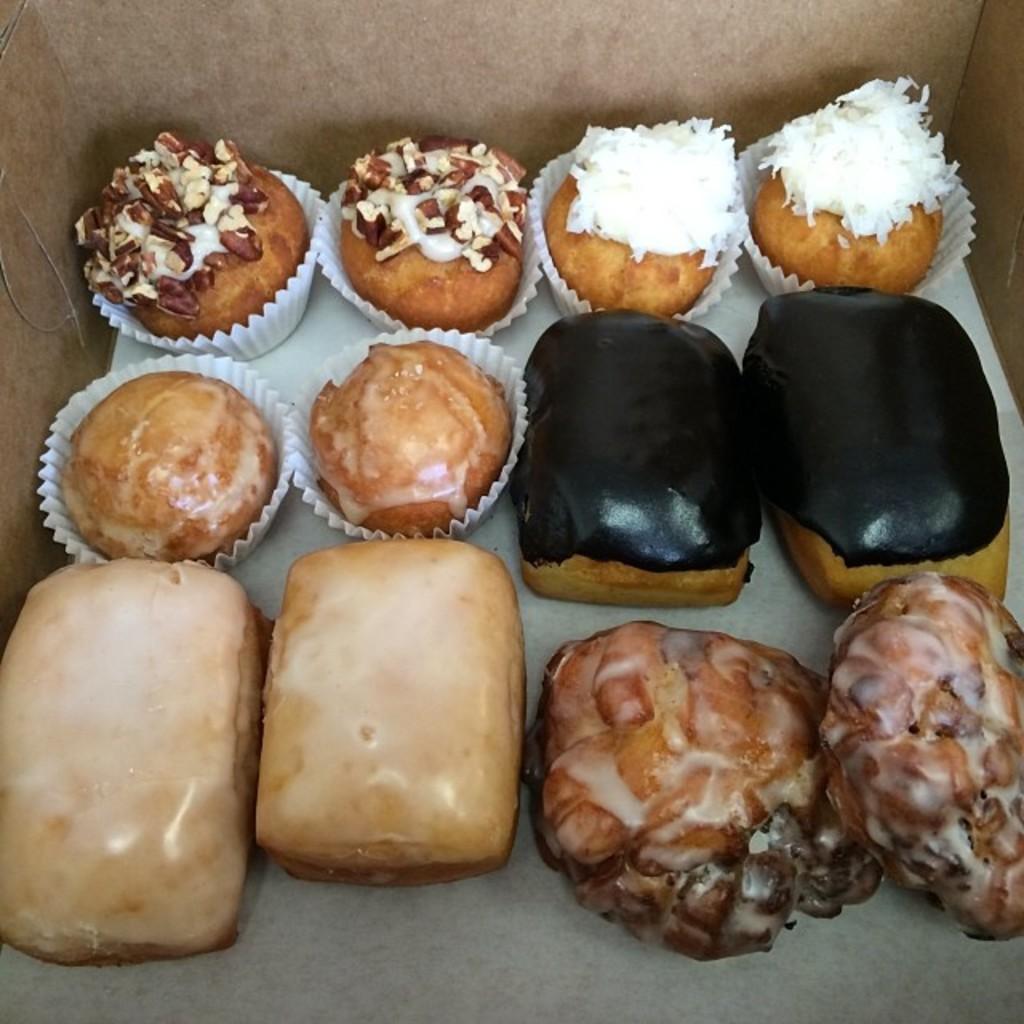How would you summarize this image in a sentence or two? In this picture there are cakes and donuts which are placed in the center of the image. 